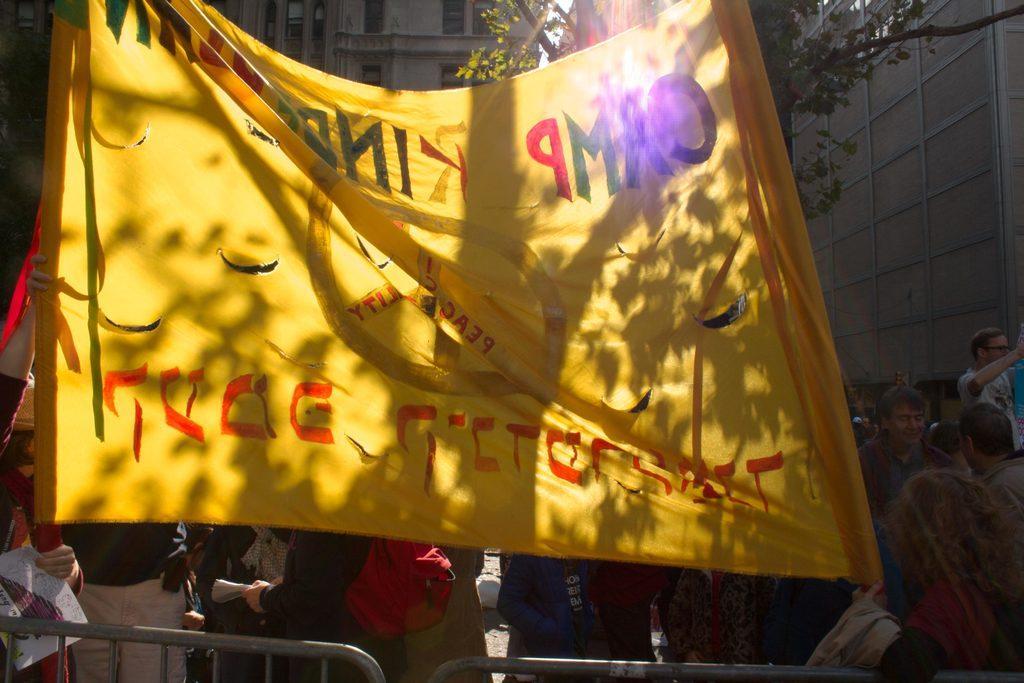How would you summarize this image in a sentence or two? In this picture I can see there are a few people standing and they are holding a banner, there is a tree behind the banner, there are a few more people standing, there is a railing. In the backdrop, there are buildings with windows and it looks like the sky is clear and sunny. 